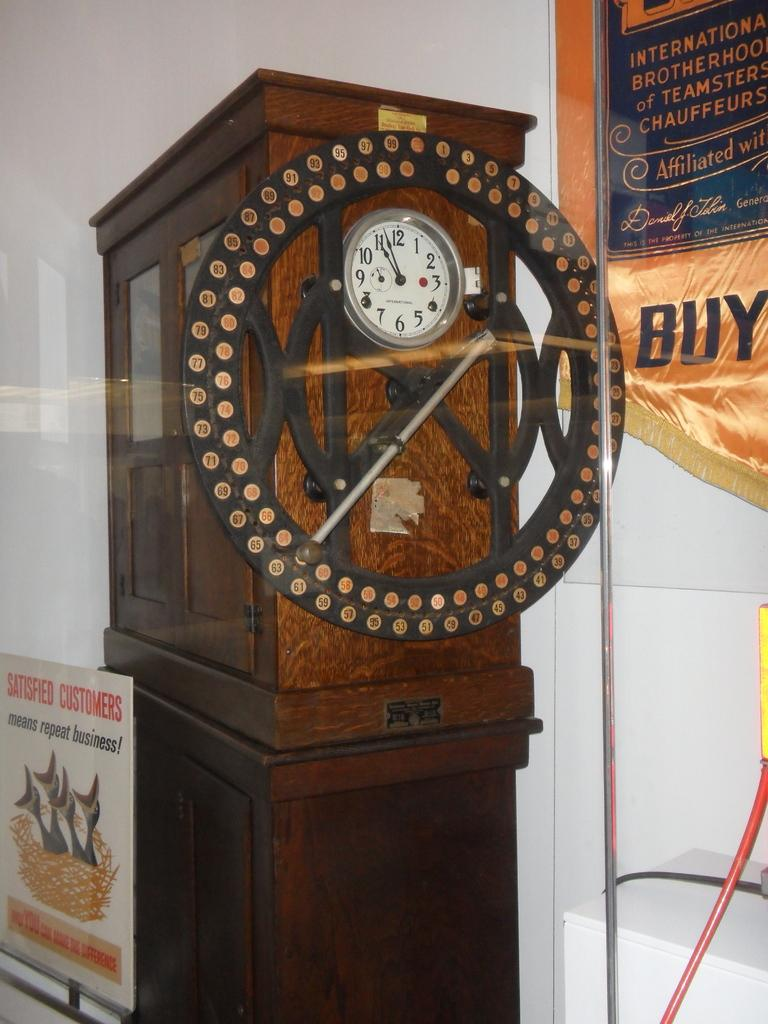<image>
Summarize the visual content of the image. A "satisfied customers" sign is next to a cabinet. 